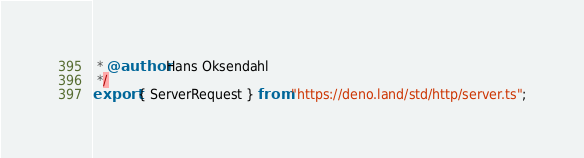Convert code to text. <code><loc_0><loc_0><loc_500><loc_500><_TypeScript_> * @author Hans Oksendahl
 */
export { ServerRequest } from "https://deno.land/std/http/server.ts";
</code> 